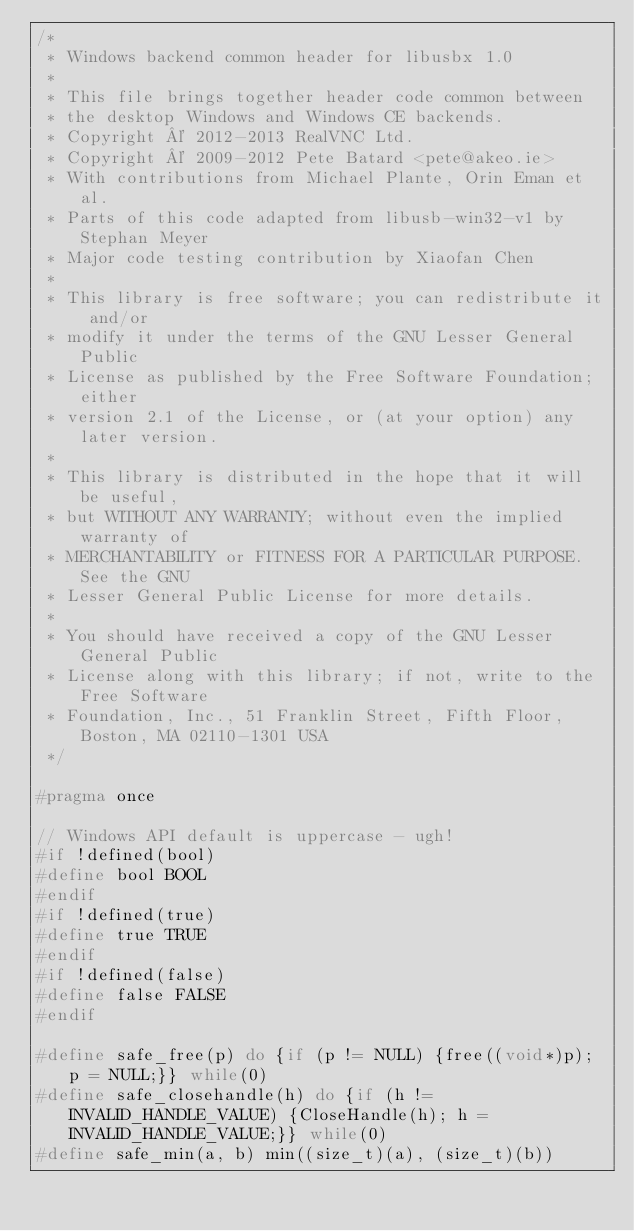Convert code to text. <code><loc_0><loc_0><loc_500><loc_500><_C_>/*
 * Windows backend common header for libusbx 1.0
 *
 * This file brings together header code common between
 * the desktop Windows and Windows CE backends.
 * Copyright © 2012-2013 RealVNC Ltd.
 * Copyright © 2009-2012 Pete Batard <pete@akeo.ie>
 * With contributions from Michael Plante, Orin Eman et al.
 * Parts of this code adapted from libusb-win32-v1 by Stephan Meyer
 * Major code testing contribution by Xiaofan Chen
 *
 * This library is free software; you can redistribute it and/or
 * modify it under the terms of the GNU Lesser General Public
 * License as published by the Free Software Foundation; either
 * version 2.1 of the License, or (at your option) any later version.
 *
 * This library is distributed in the hope that it will be useful,
 * but WITHOUT ANY WARRANTY; without even the implied warranty of
 * MERCHANTABILITY or FITNESS FOR A PARTICULAR PURPOSE.  See the GNU
 * Lesser General Public License for more details.
 *
 * You should have received a copy of the GNU Lesser General Public
 * License along with this library; if not, write to the Free Software
 * Foundation, Inc., 51 Franklin Street, Fifth Floor, Boston, MA 02110-1301 USA
 */

#pragma once

// Windows API default is uppercase - ugh!
#if !defined(bool)
#define bool BOOL
#endif
#if !defined(true)
#define true TRUE
#endif
#if !defined(false)
#define false FALSE
#endif

#define safe_free(p) do {if (p != NULL) {free((void*)p); p = NULL;}} while(0)
#define safe_closehandle(h) do {if (h != INVALID_HANDLE_VALUE) {CloseHandle(h); h = INVALID_HANDLE_VALUE;}} while(0)
#define safe_min(a, b) min((size_t)(a), (size_t)(b))</code> 